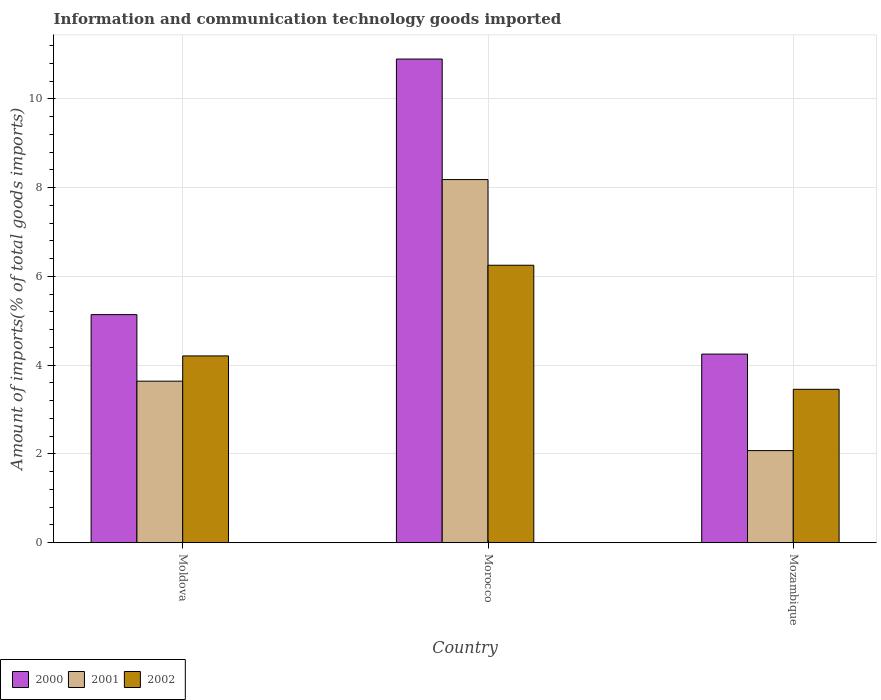How many different coloured bars are there?
Provide a succinct answer. 3. How many groups of bars are there?
Ensure brevity in your answer.  3. What is the label of the 2nd group of bars from the left?
Make the answer very short. Morocco. What is the amount of goods imported in 2001 in Moldova?
Make the answer very short. 3.64. Across all countries, what is the maximum amount of goods imported in 2002?
Your answer should be compact. 6.25. Across all countries, what is the minimum amount of goods imported in 2002?
Offer a terse response. 3.46. In which country was the amount of goods imported in 2000 maximum?
Provide a succinct answer. Morocco. In which country was the amount of goods imported in 2000 minimum?
Ensure brevity in your answer.  Mozambique. What is the total amount of goods imported in 2002 in the graph?
Your answer should be very brief. 13.92. What is the difference between the amount of goods imported in 2001 in Moldova and that in Mozambique?
Keep it short and to the point. 1.56. What is the difference between the amount of goods imported in 2000 in Mozambique and the amount of goods imported in 2001 in Moldova?
Make the answer very short. 0.61. What is the average amount of goods imported in 2001 per country?
Provide a short and direct response. 4.63. What is the difference between the amount of goods imported of/in 2001 and amount of goods imported of/in 2002 in Morocco?
Your answer should be very brief. 1.93. What is the ratio of the amount of goods imported in 2002 in Moldova to that in Morocco?
Make the answer very short. 0.67. Is the amount of goods imported in 2001 in Morocco less than that in Mozambique?
Your response must be concise. No. What is the difference between the highest and the second highest amount of goods imported in 2002?
Provide a short and direct response. -0.75. What is the difference between the highest and the lowest amount of goods imported in 2001?
Your response must be concise. 6.11. Is it the case that in every country, the sum of the amount of goods imported in 2002 and amount of goods imported in 2000 is greater than the amount of goods imported in 2001?
Offer a terse response. Yes. How many bars are there?
Provide a succinct answer. 9. How many countries are there in the graph?
Provide a succinct answer. 3. What is the difference between two consecutive major ticks on the Y-axis?
Your answer should be compact. 2. Are the values on the major ticks of Y-axis written in scientific E-notation?
Ensure brevity in your answer.  No. Does the graph contain any zero values?
Your response must be concise. No. Does the graph contain grids?
Ensure brevity in your answer.  Yes. How are the legend labels stacked?
Your response must be concise. Horizontal. What is the title of the graph?
Your answer should be very brief. Information and communication technology goods imported. Does "1974" appear as one of the legend labels in the graph?
Your answer should be compact. No. What is the label or title of the X-axis?
Offer a terse response. Country. What is the label or title of the Y-axis?
Provide a succinct answer. Amount of imports(% of total goods imports). What is the Amount of imports(% of total goods imports) of 2000 in Moldova?
Give a very brief answer. 5.14. What is the Amount of imports(% of total goods imports) of 2001 in Moldova?
Keep it short and to the point. 3.64. What is the Amount of imports(% of total goods imports) of 2002 in Moldova?
Make the answer very short. 4.21. What is the Amount of imports(% of total goods imports) in 2000 in Morocco?
Provide a succinct answer. 10.9. What is the Amount of imports(% of total goods imports) of 2001 in Morocco?
Ensure brevity in your answer.  8.18. What is the Amount of imports(% of total goods imports) in 2002 in Morocco?
Make the answer very short. 6.25. What is the Amount of imports(% of total goods imports) in 2000 in Mozambique?
Offer a terse response. 4.25. What is the Amount of imports(% of total goods imports) in 2001 in Mozambique?
Your response must be concise. 2.08. What is the Amount of imports(% of total goods imports) in 2002 in Mozambique?
Provide a succinct answer. 3.46. Across all countries, what is the maximum Amount of imports(% of total goods imports) of 2000?
Give a very brief answer. 10.9. Across all countries, what is the maximum Amount of imports(% of total goods imports) of 2001?
Your answer should be compact. 8.18. Across all countries, what is the maximum Amount of imports(% of total goods imports) in 2002?
Your response must be concise. 6.25. Across all countries, what is the minimum Amount of imports(% of total goods imports) in 2000?
Your answer should be compact. 4.25. Across all countries, what is the minimum Amount of imports(% of total goods imports) of 2001?
Your response must be concise. 2.08. Across all countries, what is the minimum Amount of imports(% of total goods imports) of 2002?
Your response must be concise. 3.46. What is the total Amount of imports(% of total goods imports) in 2000 in the graph?
Your answer should be very brief. 20.29. What is the total Amount of imports(% of total goods imports) of 2001 in the graph?
Your answer should be compact. 13.9. What is the total Amount of imports(% of total goods imports) of 2002 in the graph?
Give a very brief answer. 13.92. What is the difference between the Amount of imports(% of total goods imports) of 2000 in Moldova and that in Morocco?
Your answer should be very brief. -5.76. What is the difference between the Amount of imports(% of total goods imports) of 2001 in Moldova and that in Morocco?
Provide a succinct answer. -4.54. What is the difference between the Amount of imports(% of total goods imports) in 2002 in Moldova and that in Morocco?
Provide a short and direct response. -2.04. What is the difference between the Amount of imports(% of total goods imports) of 2000 in Moldova and that in Mozambique?
Your answer should be compact. 0.89. What is the difference between the Amount of imports(% of total goods imports) in 2001 in Moldova and that in Mozambique?
Offer a terse response. 1.56. What is the difference between the Amount of imports(% of total goods imports) of 2002 in Moldova and that in Mozambique?
Your answer should be very brief. 0.75. What is the difference between the Amount of imports(% of total goods imports) of 2000 in Morocco and that in Mozambique?
Give a very brief answer. 6.65. What is the difference between the Amount of imports(% of total goods imports) of 2001 in Morocco and that in Mozambique?
Give a very brief answer. 6.11. What is the difference between the Amount of imports(% of total goods imports) of 2002 in Morocco and that in Mozambique?
Your response must be concise. 2.8. What is the difference between the Amount of imports(% of total goods imports) in 2000 in Moldova and the Amount of imports(% of total goods imports) in 2001 in Morocco?
Provide a short and direct response. -3.04. What is the difference between the Amount of imports(% of total goods imports) in 2000 in Moldova and the Amount of imports(% of total goods imports) in 2002 in Morocco?
Make the answer very short. -1.11. What is the difference between the Amount of imports(% of total goods imports) in 2001 in Moldova and the Amount of imports(% of total goods imports) in 2002 in Morocco?
Give a very brief answer. -2.61. What is the difference between the Amount of imports(% of total goods imports) in 2000 in Moldova and the Amount of imports(% of total goods imports) in 2001 in Mozambique?
Offer a very short reply. 3.06. What is the difference between the Amount of imports(% of total goods imports) of 2000 in Moldova and the Amount of imports(% of total goods imports) of 2002 in Mozambique?
Your answer should be very brief. 1.68. What is the difference between the Amount of imports(% of total goods imports) in 2001 in Moldova and the Amount of imports(% of total goods imports) in 2002 in Mozambique?
Give a very brief answer. 0.18. What is the difference between the Amount of imports(% of total goods imports) in 2000 in Morocco and the Amount of imports(% of total goods imports) in 2001 in Mozambique?
Your answer should be very brief. 8.82. What is the difference between the Amount of imports(% of total goods imports) of 2000 in Morocco and the Amount of imports(% of total goods imports) of 2002 in Mozambique?
Your answer should be compact. 7.44. What is the difference between the Amount of imports(% of total goods imports) in 2001 in Morocco and the Amount of imports(% of total goods imports) in 2002 in Mozambique?
Offer a terse response. 4.73. What is the average Amount of imports(% of total goods imports) of 2000 per country?
Your answer should be very brief. 6.76. What is the average Amount of imports(% of total goods imports) in 2001 per country?
Ensure brevity in your answer.  4.63. What is the average Amount of imports(% of total goods imports) of 2002 per country?
Make the answer very short. 4.64. What is the difference between the Amount of imports(% of total goods imports) in 2000 and Amount of imports(% of total goods imports) in 2001 in Moldova?
Provide a succinct answer. 1.5. What is the difference between the Amount of imports(% of total goods imports) of 2000 and Amount of imports(% of total goods imports) of 2002 in Moldova?
Your answer should be very brief. 0.93. What is the difference between the Amount of imports(% of total goods imports) in 2001 and Amount of imports(% of total goods imports) in 2002 in Moldova?
Ensure brevity in your answer.  -0.57. What is the difference between the Amount of imports(% of total goods imports) of 2000 and Amount of imports(% of total goods imports) of 2001 in Morocco?
Offer a terse response. 2.72. What is the difference between the Amount of imports(% of total goods imports) of 2000 and Amount of imports(% of total goods imports) of 2002 in Morocco?
Provide a short and direct response. 4.65. What is the difference between the Amount of imports(% of total goods imports) of 2001 and Amount of imports(% of total goods imports) of 2002 in Morocco?
Your answer should be very brief. 1.93. What is the difference between the Amount of imports(% of total goods imports) in 2000 and Amount of imports(% of total goods imports) in 2001 in Mozambique?
Give a very brief answer. 2.17. What is the difference between the Amount of imports(% of total goods imports) in 2000 and Amount of imports(% of total goods imports) in 2002 in Mozambique?
Provide a short and direct response. 0.79. What is the difference between the Amount of imports(% of total goods imports) in 2001 and Amount of imports(% of total goods imports) in 2002 in Mozambique?
Your answer should be very brief. -1.38. What is the ratio of the Amount of imports(% of total goods imports) in 2000 in Moldova to that in Morocco?
Provide a short and direct response. 0.47. What is the ratio of the Amount of imports(% of total goods imports) of 2001 in Moldova to that in Morocco?
Provide a short and direct response. 0.44. What is the ratio of the Amount of imports(% of total goods imports) in 2002 in Moldova to that in Morocco?
Keep it short and to the point. 0.67. What is the ratio of the Amount of imports(% of total goods imports) in 2000 in Moldova to that in Mozambique?
Keep it short and to the point. 1.21. What is the ratio of the Amount of imports(% of total goods imports) of 2001 in Moldova to that in Mozambique?
Give a very brief answer. 1.75. What is the ratio of the Amount of imports(% of total goods imports) of 2002 in Moldova to that in Mozambique?
Your response must be concise. 1.22. What is the ratio of the Amount of imports(% of total goods imports) in 2000 in Morocco to that in Mozambique?
Ensure brevity in your answer.  2.56. What is the ratio of the Amount of imports(% of total goods imports) in 2001 in Morocco to that in Mozambique?
Your answer should be very brief. 3.94. What is the ratio of the Amount of imports(% of total goods imports) of 2002 in Morocco to that in Mozambique?
Give a very brief answer. 1.81. What is the difference between the highest and the second highest Amount of imports(% of total goods imports) of 2000?
Ensure brevity in your answer.  5.76. What is the difference between the highest and the second highest Amount of imports(% of total goods imports) in 2001?
Make the answer very short. 4.54. What is the difference between the highest and the second highest Amount of imports(% of total goods imports) in 2002?
Your answer should be very brief. 2.04. What is the difference between the highest and the lowest Amount of imports(% of total goods imports) in 2000?
Your response must be concise. 6.65. What is the difference between the highest and the lowest Amount of imports(% of total goods imports) of 2001?
Provide a short and direct response. 6.11. What is the difference between the highest and the lowest Amount of imports(% of total goods imports) in 2002?
Give a very brief answer. 2.8. 